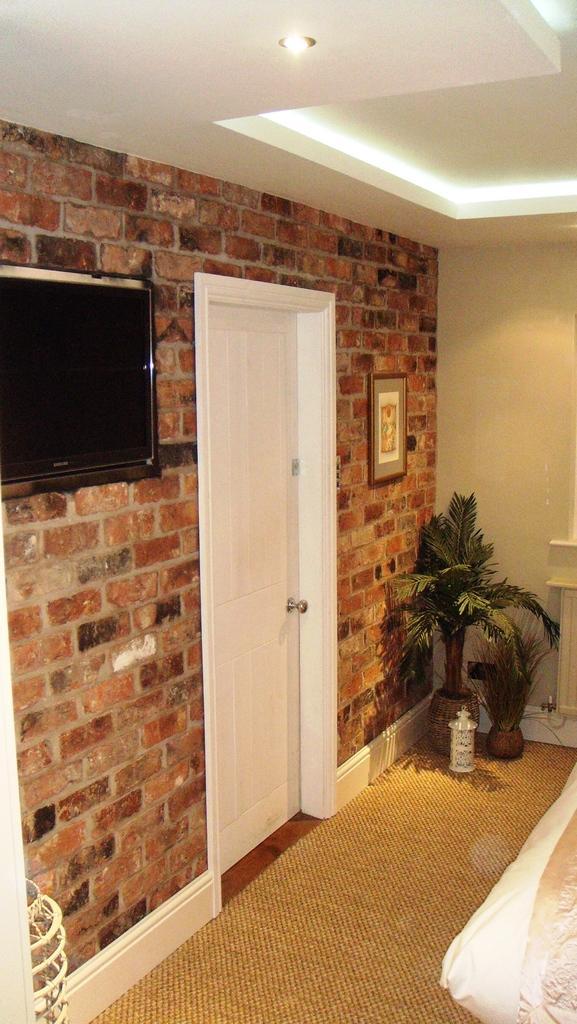Please provide a concise description of this image. This image is clicked in a room. On the bottom of the image there is a bed and plants on the surface. On the left side there is a TV attached to the wall, beside the TV there is a door and frame. At the top of the image there is a ceiling. 